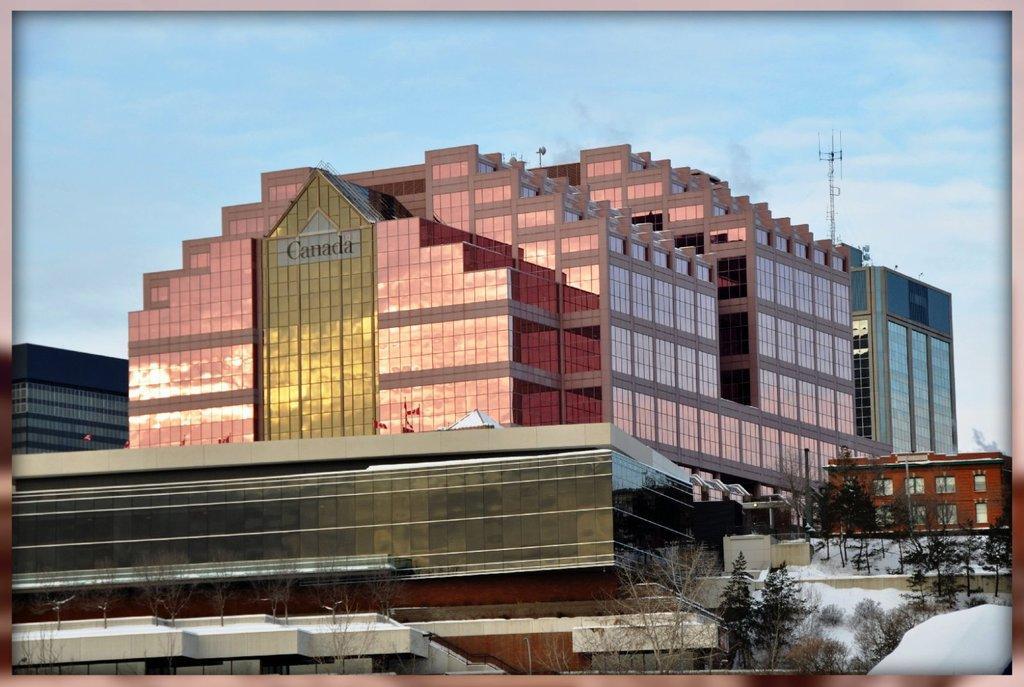Can you describe this image briefly? In this image there are buildings. At the bottom there is snow and trees. In the background there is sky and we can see a tower. 